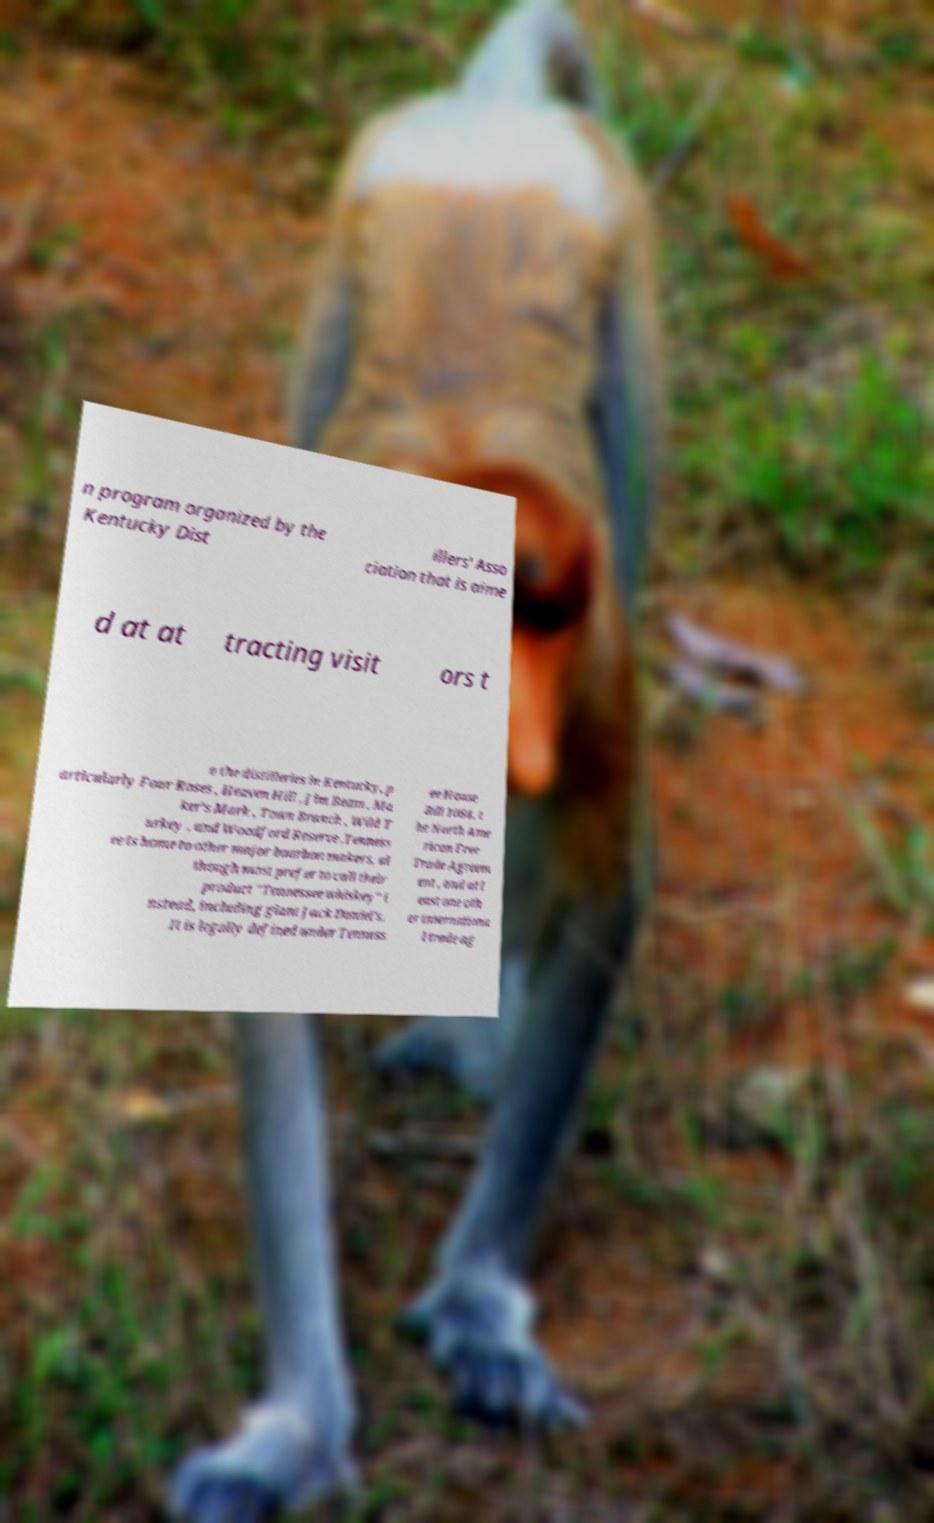For documentation purposes, I need the text within this image transcribed. Could you provide that? n program organized by the Kentucky Dist illers' Asso ciation that is aime d at at tracting visit ors t o the distilleries in Kentucky, p articularly Four Roses , Heaven Hill , Jim Beam , Ma ker's Mark , Town Branch , Wild T urkey , and Woodford Reserve .Tenness ee is home to other major bourbon makers, al though most prefer to call their product "Tennessee whiskey" i nstead, including giant Jack Daniel's. It is legally defined under Tenness ee House Bill 1084, t he North Ame rican Free Trade Agreem ent , and at l east one oth er internationa l trade ag 